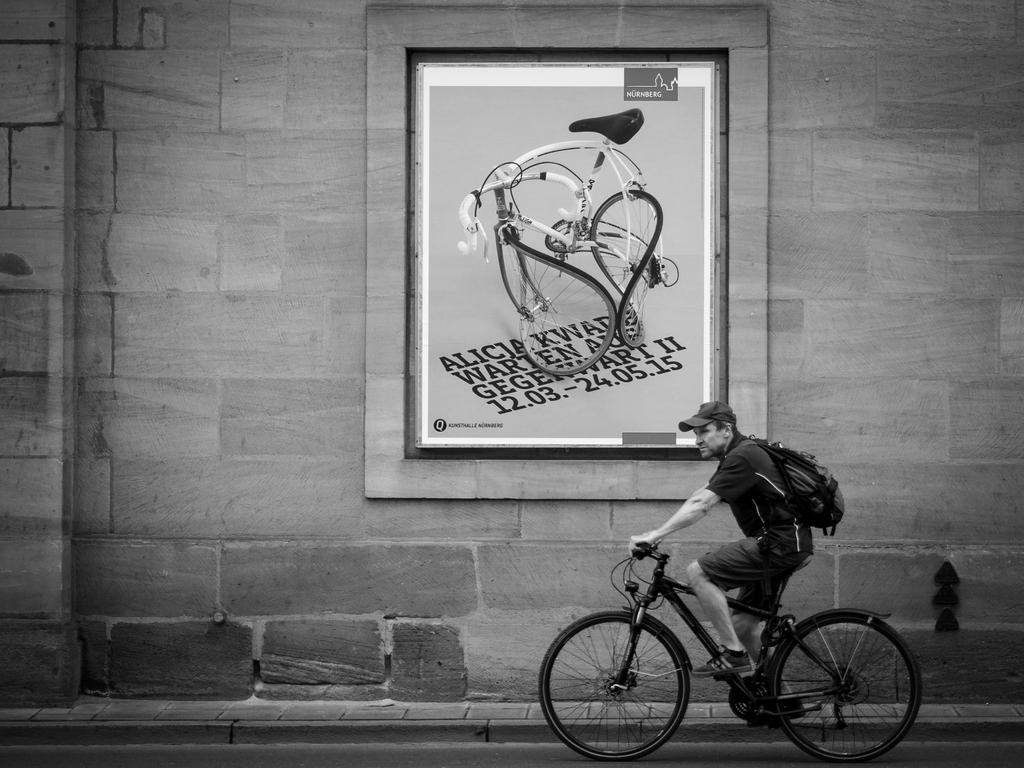What is the man in the image doing? The man is cycling a bicycle in the image. Where is the bicycle located? The bicycle is on the road. What can be seen in the background of the image? There is an advertisement poster on a wall in the background. What is the man carrying while cycling? The man is carrying a bag on his shoulders. What is the man's afterthought while cycling in the image? There is no indication of the man having an afterthought in the image. Can you hear the man talking to someone in the image? The image is silent, so we cannot hear the man talking to someone. 